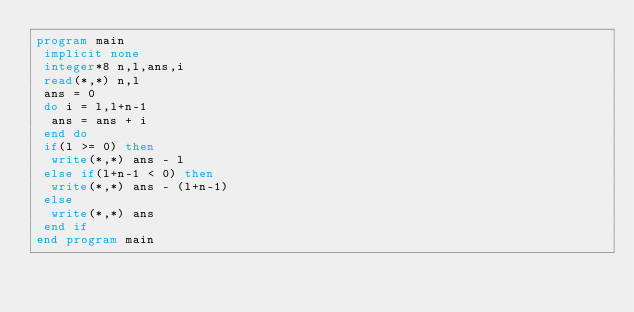Convert code to text. <code><loc_0><loc_0><loc_500><loc_500><_FORTRAN_>program main
 implicit none
 integer*8 n,l,ans,i
 read(*,*) n,l
 ans = 0
 do i = l,l+n-1
  ans = ans + i
 end do
 if(l >= 0) then
  write(*,*) ans - l
 else if(l+n-1 < 0) then
  write(*,*) ans - (l+n-1)
 else
  write(*,*) ans
 end if
end program main</code> 